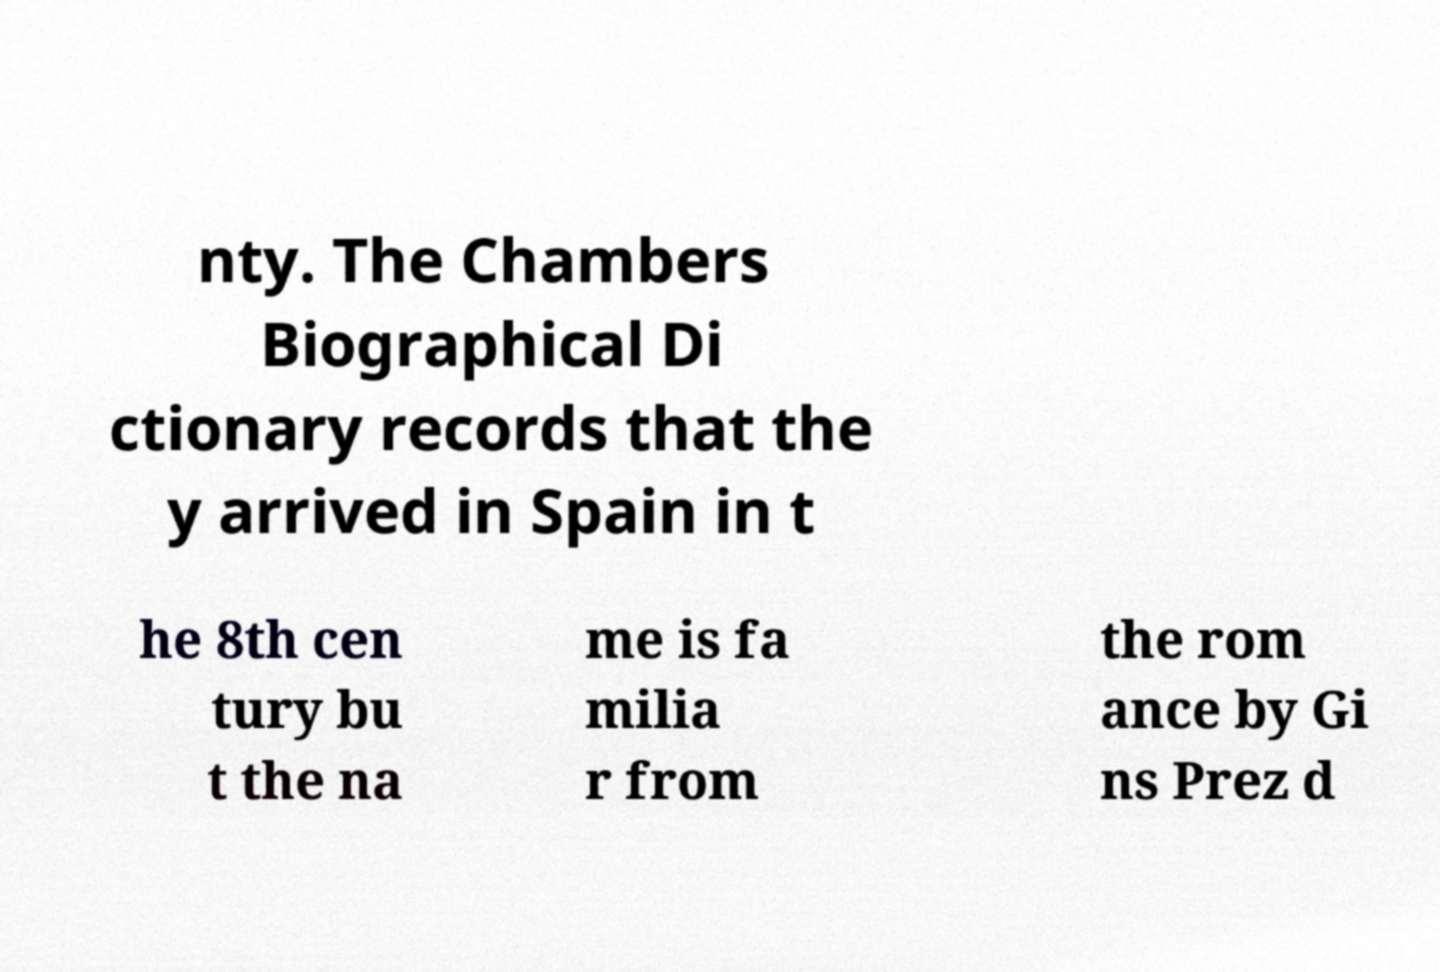Could you assist in decoding the text presented in this image and type it out clearly? nty. The Chambers Biographical Di ctionary records that the y arrived in Spain in t he 8th cen tury bu t the na me is fa milia r from the rom ance by Gi ns Prez d 